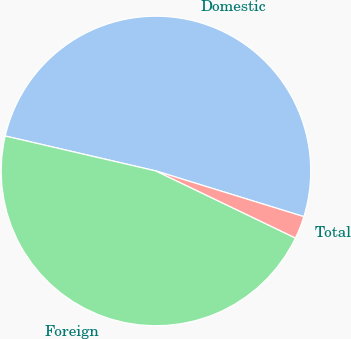Convert chart. <chart><loc_0><loc_0><loc_500><loc_500><pie_chart><fcel>Domestic<fcel>Foreign<fcel>Total<nl><fcel>51.14%<fcel>46.5%<fcel>2.36%<nl></chart> 